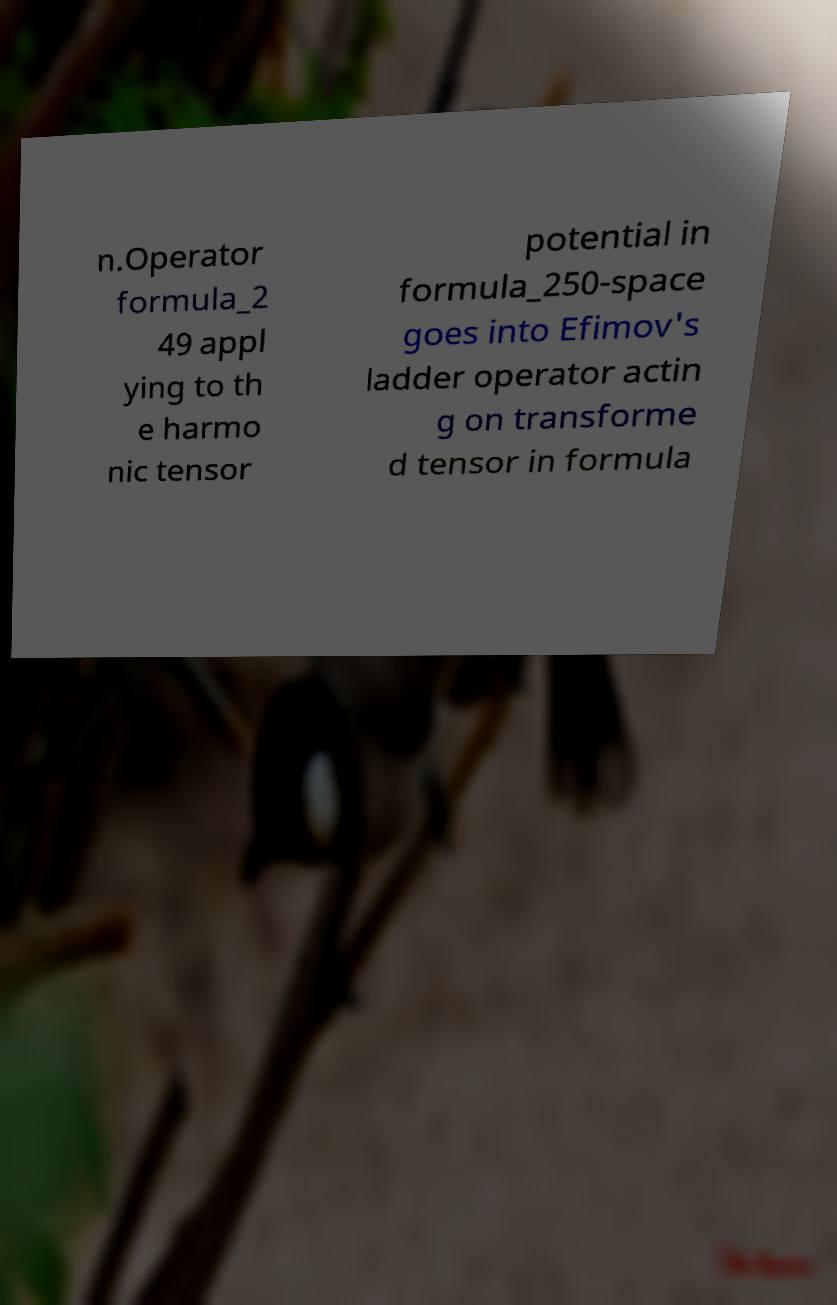What messages or text are displayed in this image? I need them in a readable, typed format. n.Operator formula_2 49 appl ying to th e harmo nic tensor potential in formula_250-space goes into Efimov's ladder operator actin g on transforme d tensor in formula 